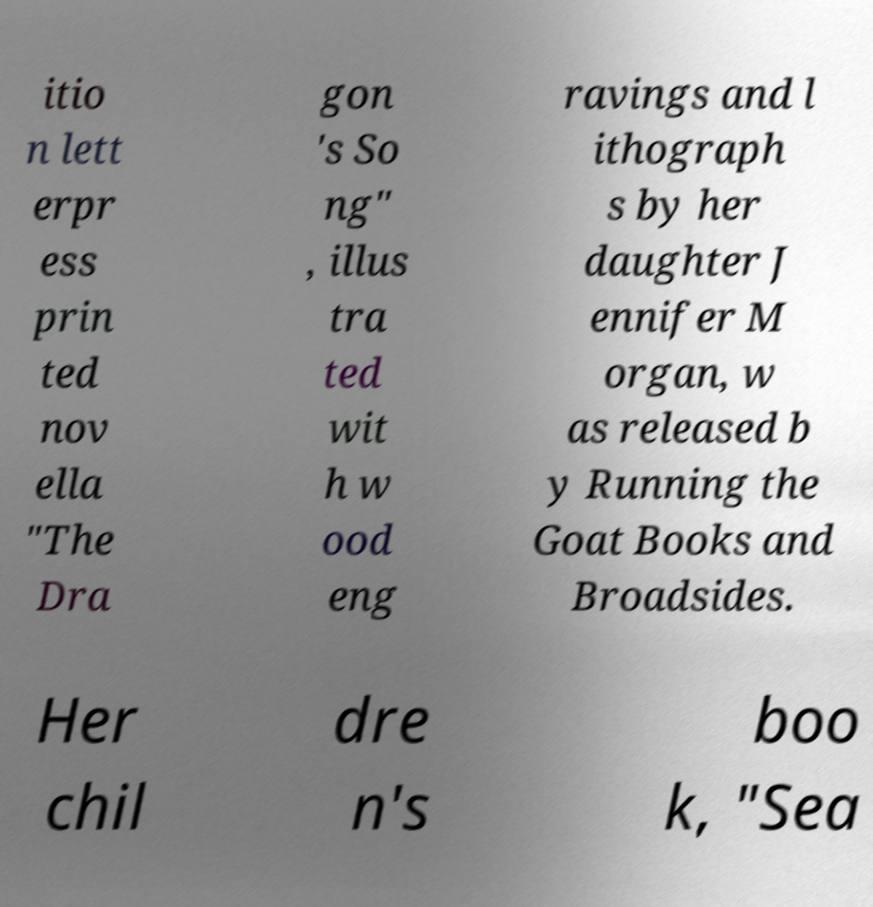Can you read and provide the text displayed in the image?This photo seems to have some interesting text. Can you extract and type it out for me? itio n lett erpr ess prin ted nov ella "The Dra gon 's So ng" , illus tra ted wit h w ood eng ravings and l ithograph s by her daughter J ennifer M organ, w as released b y Running the Goat Books and Broadsides. Her chil dre n's boo k, "Sea 